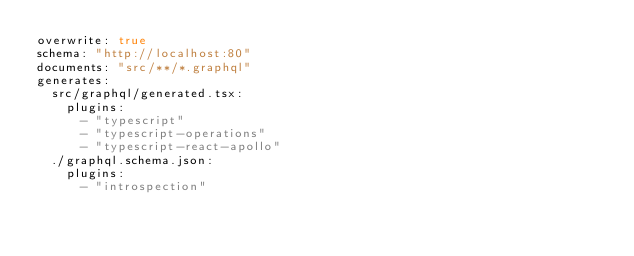<code> <loc_0><loc_0><loc_500><loc_500><_YAML_>overwrite: true
schema: "http://localhost:80"
documents: "src/**/*.graphql"
generates:
  src/graphql/generated.tsx:
    plugins:
      - "typescript"
      - "typescript-operations"
      - "typescript-react-apollo"
  ./graphql.schema.json:
    plugins:
      - "introspection"
</code> 